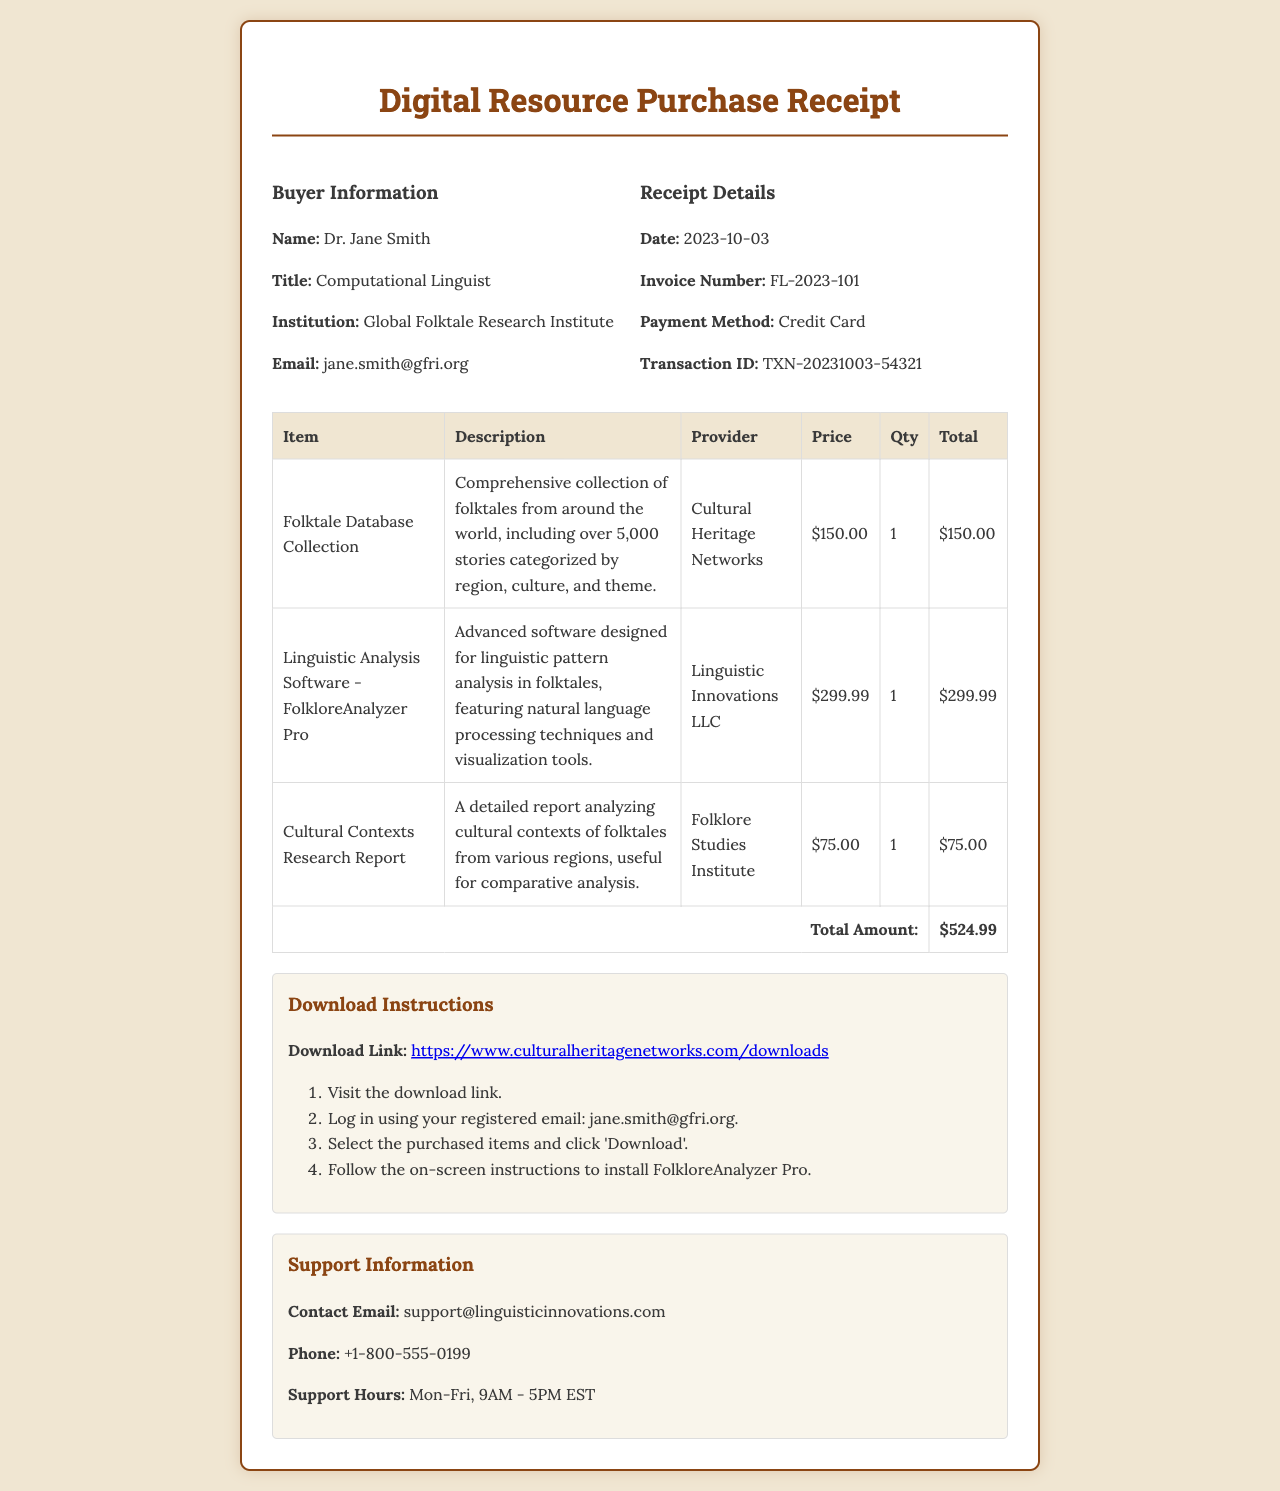What is the buyer's name? The buyer's name is mentioned in the document as Dr. Jane Smith under Buyer Information.
Answer: Dr. Jane Smith What is the invoice number? The invoice number is listed under Receipt Details, which helps in identifying the transaction.
Answer: FL-2023-101 How much did the Linguistic Analysis Software cost? The cost of the Linguistic Analysis Software is shown in the table under the Price column.
Answer: $299.99 When was the purchase made? The purchase date is given in Receipt Details, indicating when the transaction occurred.
Answer: 2023-10-03 What is the total amount of the purchase? The total amount is calculated from the sum of all items in the table, which is presented in the footer.
Answer: $524.99 What is the download link provided in the document? The document contains a specific link for downloading the purchased resources, located in the Download Instructions section.
Answer: https://www.culturalheritagenetworks.com/downloads How many stories are included in the Folktale Database Collection? The number of stories included in the Folktale Database Collection is stated within its description.
Answer: over 5,000 stories What support contact method is provided? The support information section indicates ways to reach out for assistance.
Answer: support@linguisticinnovations.com What is the support phone number? The support phone number is listed in the Support Information section of the receipt.
Answer: +1-800-555-0199 